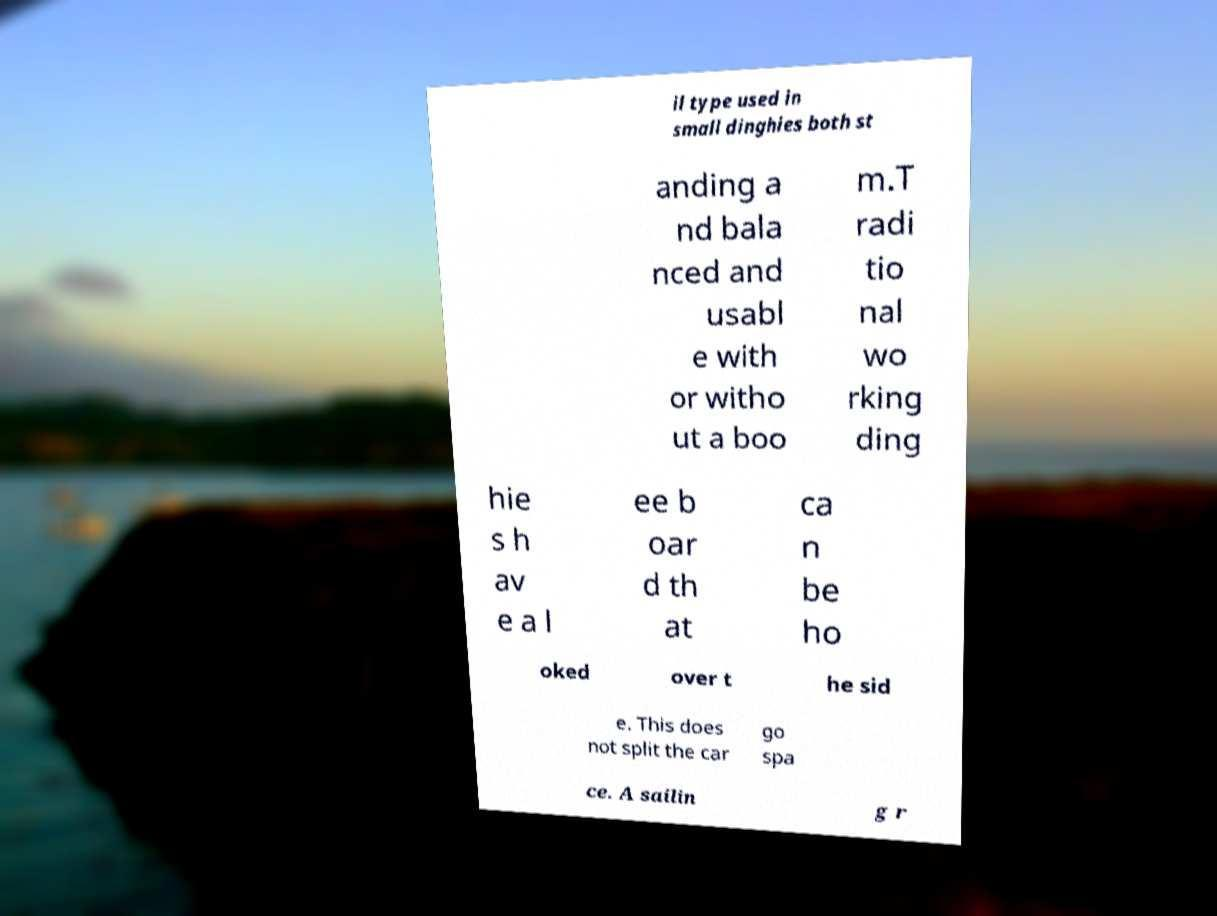Please identify and transcribe the text found in this image. il type used in small dinghies both st anding a nd bala nced and usabl e with or witho ut a boo m.T radi tio nal wo rking ding hie s h av e a l ee b oar d th at ca n be ho oked over t he sid e. This does not split the car go spa ce. A sailin g r 